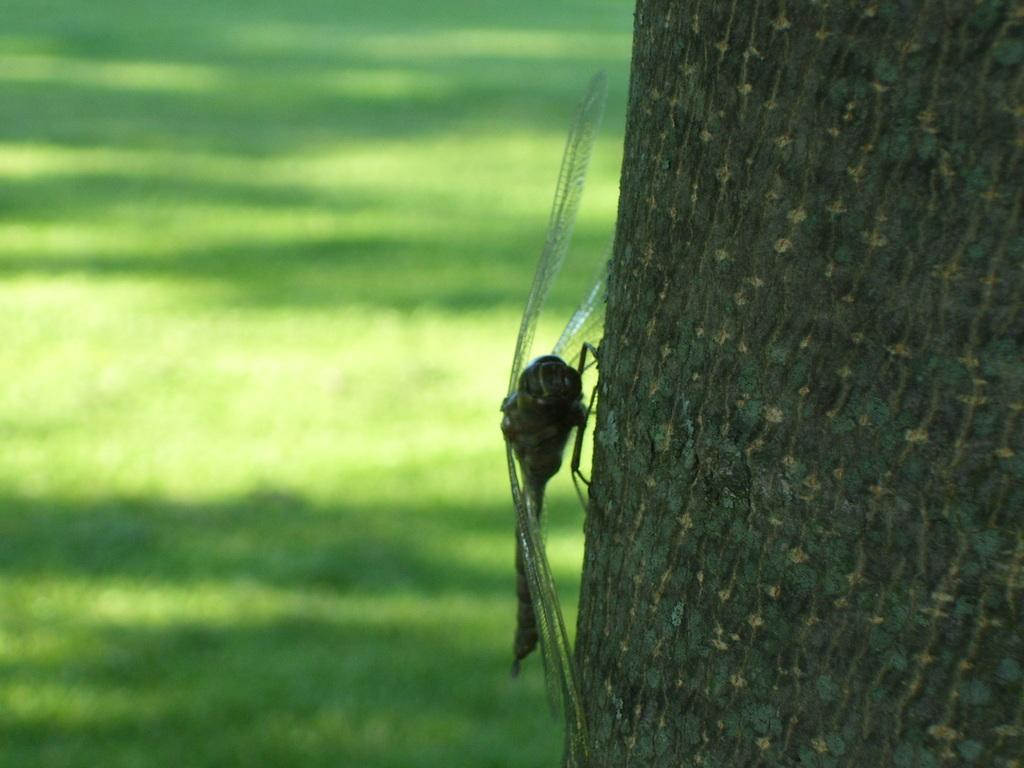What is the main subject in the foreground of the picture? There is a trunk of a tree in the foreground of the picture. Are there any living creatures on the trunk? Yes, a dragonfly is present on the trunk. What can be seen in the background towards the left? There is greenery in the background towards the left. How many brothers are depicted playing with the dragonfly in the image? There are no brothers present in the image; it only features a dragonfly on the trunk of a tree. What type of beast can be seen interacting with the greenery in the background? There is no beast present in the image; only the trunk of a tree, a dragonfly, and greenery in the background are visible. 